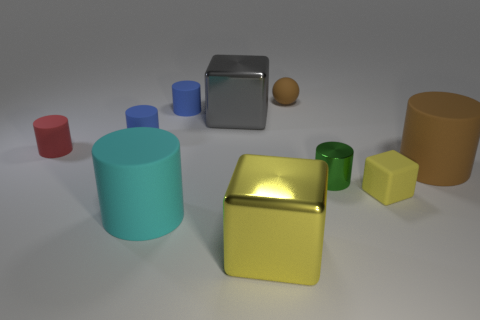How are the containers in this image different from one another? The containers vary in several ways: color, size, and shape. For instance, one cylinder is teal while the other is orange, and the metallic container has a reflective surface unlike the matte textures of the others. They also have different heights and diameters, adding to the variety. Can you tell me more about the different shapes displayed? Certainly! The image showcases basic geometric shapes like cylinders, cubes, and spheres. The cylinders have circular bases and different heights, the cubes have equal lengths on all sides, and the spheres are perfectly round. Each object's shape contributes to a study of geometrical forms. 